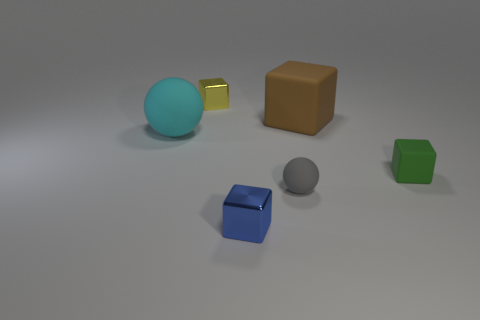Subtract all blue metal cubes. How many cubes are left? 3 Add 4 large spheres. How many objects exist? 10 Subtract all cyan spheres. How many spheres are left? 1 Subtract 4 blocks. How many blocks are left? 0 Subtract 0 yellow spheres. How many objects are left? 6 Subtract all cubes. How many objects are left? 2 Subtract all red spheres. Subtract all purple cylinders. How many spheres are left? 2 Subtract all green cubes. How many cyan balls are left? 1 Subtract all brown cylinders. Subtract all big rubber cubes. How many objects are left? 5 Add 2 big brown matte things. How many big brown matte things are left? 3 